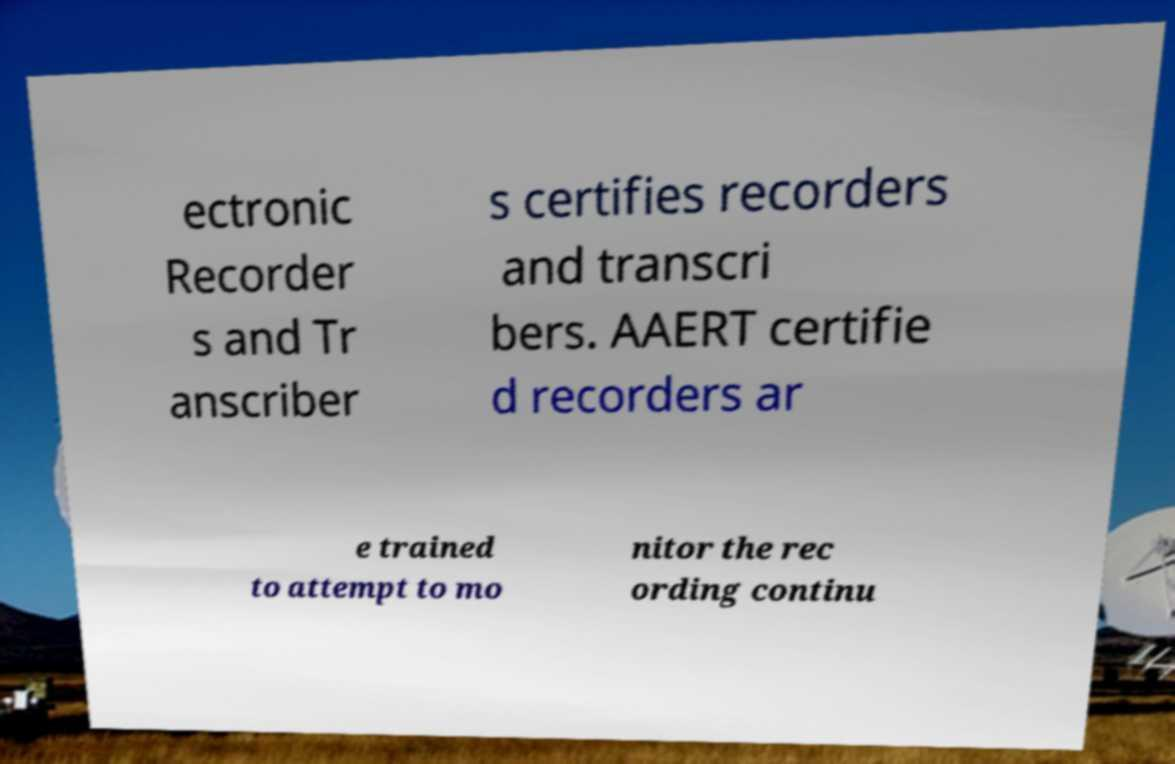Can you read and provide the text displayed in the image?This photo seems to have some interesting text. Can you extract and type it out for me? ectronic Recorder s and Tr anscriber s certifies recorders and transcri bers. AAERT certifie d recorders ar e trained to attempt to mo nitor the rec ording continu 